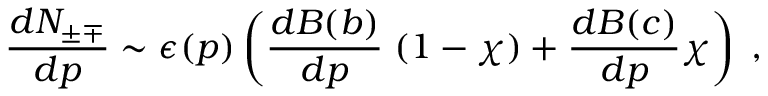<formula> <loc_0><loc_0><loc_500><loc_500>\frac { d N _ { \pm \mp } } { d p } \sim \epsilon ( p ) \left ( \frac { d B ( b ) } { d p } \, ( 1 - \chi ) + \frac { d B ( c ) } { d p } \chi \right ) \, ,</formula> 